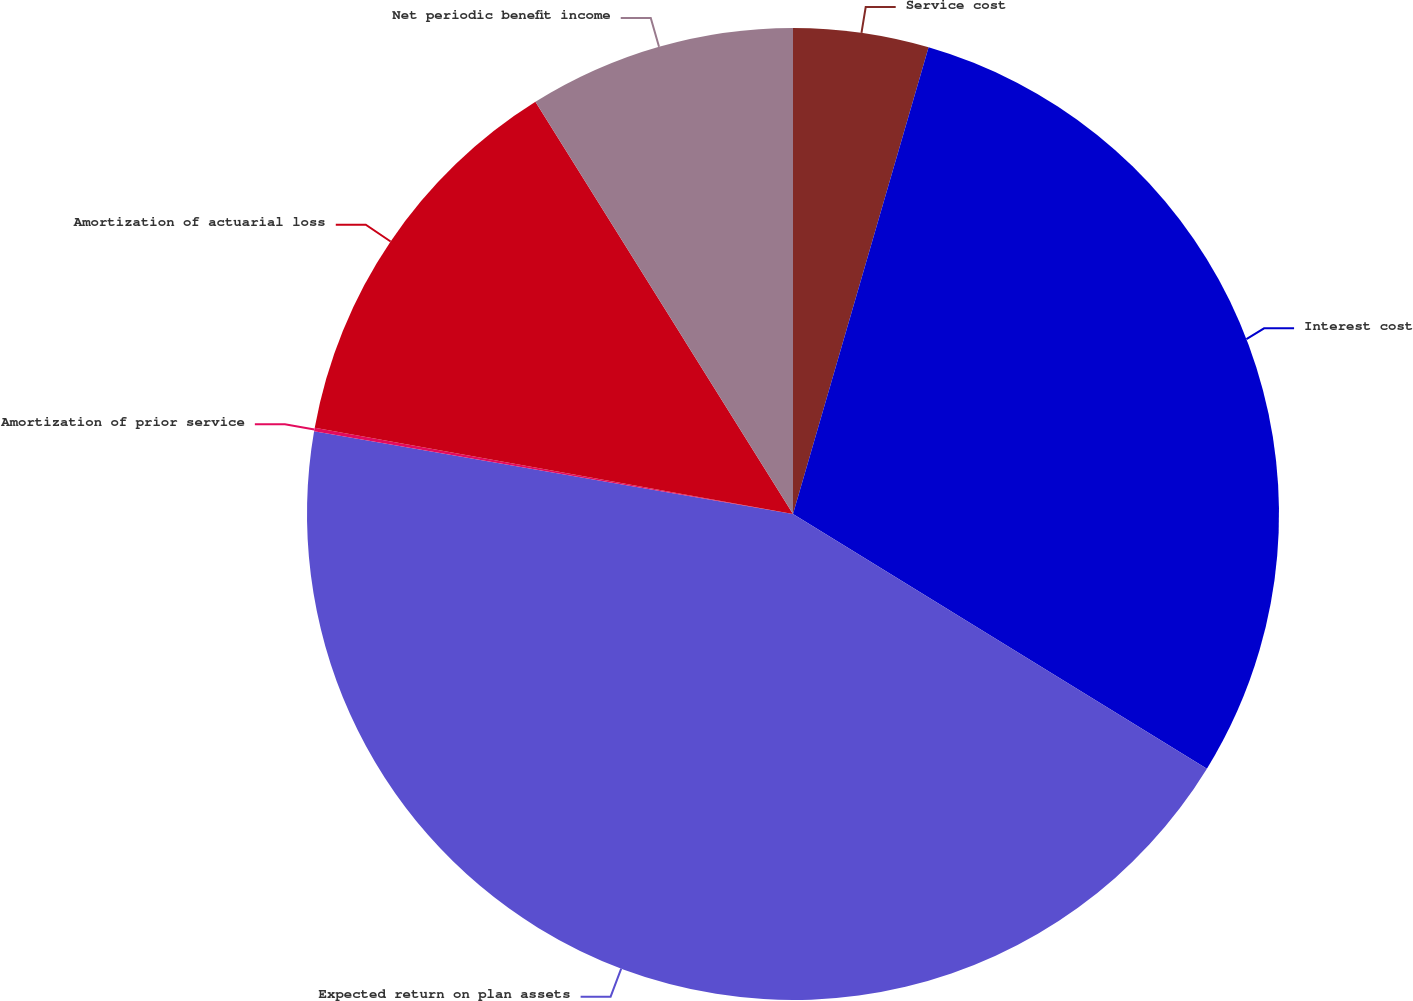Convert chart. <chart><loc_0><loc_0><loc_500><loc_500><pie_chart><fcel>Service cost<fcel>Interest cost<fcel>Expected return on plan assets<fcel>Amortization of prior service<fcel>Amortization of actuarial loss<fcel>Net periodic benefit income<nl><fcel>4.5%<fcel>29.28%<fcel>43.94%<fcel>0.12%<fcel>13.27%<fcel>8.89%<nl></chart> 